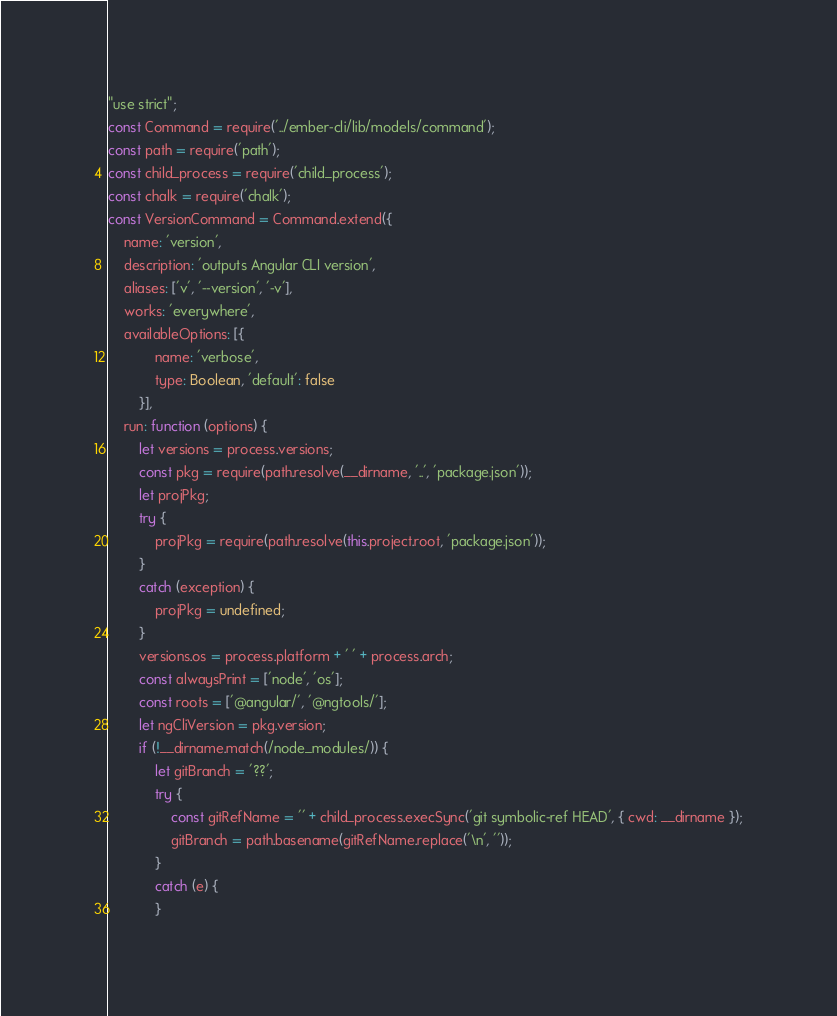Convert code to text. <code><loc_0><loc_0><loc_500><loc_500><_JavaScript_>"use strict";
const Command = require('../ember-cli/lib/models/command');
const path = require('path');
const child_process = require('child_process');
const chalk = require('chalk');
const VersionCommand = Command.extend({
    name: 'version',
    description: 'outputs Angular CLI version',
    aliases: ['v', '--version', '-v'],
    works: 'everywhere',
    availableOptions: [{
            name: 'verbose',
            type: Boolean, 'default': false
        }],
    run: function (options) {
        let versions = process.versions;
        const pkg = require(path.resolve(__dirname, '..', 'package.json'));
        let projPkg;
        try {
            projPkg = require(path.resolve(this.project.root, 'package.json'));
        }
        catch (exception) {
            projPkg = undefined;
        }
        versions.os = process.platform + ' ' + process.arch;
        const alwaysPrint = ['node', 'os'];
        const roots = ['@angular/', '@ngtools/'];
        let ngCliVersion = pkg.version;
        if (!__dirname.match(/node_modules/)) {
            let gitBranch = '??';
            try {
                const gitRefName = '' + child_process.execSync('git symbolic-ref HEAD', { cwd: __dirname });
                gitBranch = path.basename(gitRefName.replace('\n', ''));
            }
            catch (e) {
            }</code> 